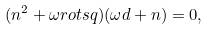Convert formula to latex. <formula><loc_0><loc_0><loc_500><loc_500>( n ^ { 2 } + \omega r o t s q ) ( \omega d + n ) = 0 ,</formula> 